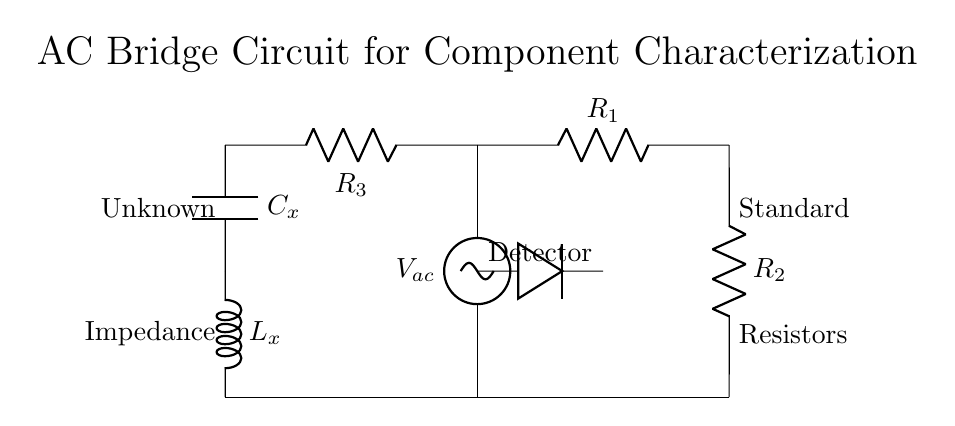What is the voltage source in this circuit? The voltage source is labeled as V_ac, which indicates that it is an alternating current voltage source.
Answer: V_ac What components are present in the left arm of the bridge? The left arm contains two resistors labeled R_1 and R_2 that are connected in series.
Answer: R_1, R_2 What is the function of the detector in this circuit? The detector is used to assess the balance of the bridge, determining if the impedance across its terminals is at a null point for effective measurement.
Answer: Measure balance What is the configuration of the right arm of the bridge? The right arm consists of a resistor R_3 in series with a capacitor C_x and an inductor L_x, indicating a combination of resistive and reactive components.
Answer: Resistor, Capacitor, and Inductor What is required for the bridge to be balanced? The bridge is balanced when the impedances in both arms are equal, leading to zero voltage across the detector. This achieves the desired measurement condition.
Answer: Equal impedances How do you determine the unknown capacitance (C_x) using this circuit? C_x can be calculated by adjusting the standard resistors until the detector indicates balance. At this point, the known values of R_1, R_2, and R_3 are used along with the frequency of the source to find C_x from the impedance formulas.
Answer: By balancing the bridge What does each label indicate at the left side of the circuit? On the left, it indicates that the unknown component is connected, while the labeled "Impedance" shows that the corresponding branch includes unknown impedances that need characterization.
Answer: Unknown and Impedance 